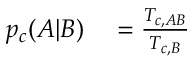<formula> <loc_0><loc_0><loc_500><loc_500>\begin{array} { r l } { p _ { c } ( A | B ) } & = \frac { T _ { c , A B } } { T _ { c , B } } } \end{array}</formula> 